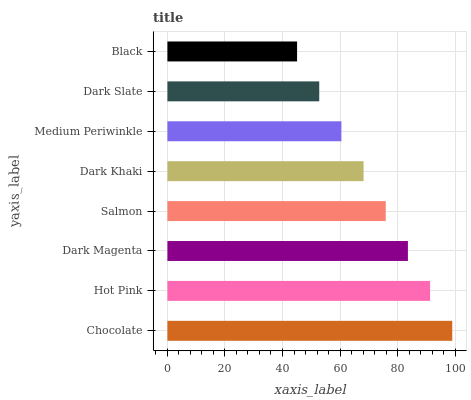Is Black the minimum?
Answer yes or no. Yes. Is Chocolate the maximum?
Answer yes or no. Yes. Is Hot Pink the minimum?
Answer yes or no. No. Is Hot Pink the maximum?
Answer yes or no. No. Is Chocolate greater than Hot Pink?
Answer yes or no. Yes. Is Hot Pink less than Chocolate?
Answer yes or no. Yes. Is Hot Pink greater than Chocolate?
Answer yes or no. No. Is Chocolate less than Hot Pink?
Answer yes or no. No. Is Salmon the high median?
Answer yes or no. Yes. Is Dark Khaki the low median?
Answer yes or no. Yes. Is Chocolate the high median?
Answer yes or no. No. Is Chocolate the low median?
Answer yes or no. No. 